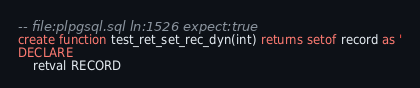<code> <loc_0><loc_0><loc_500><loc_500><_SQL_>-- file:plpgsql.sql ln:1526 expect:true
create function test_ret_set_rec_dyn(int) returns setof record as '
DECLARE
	retval RECORD
</code> 